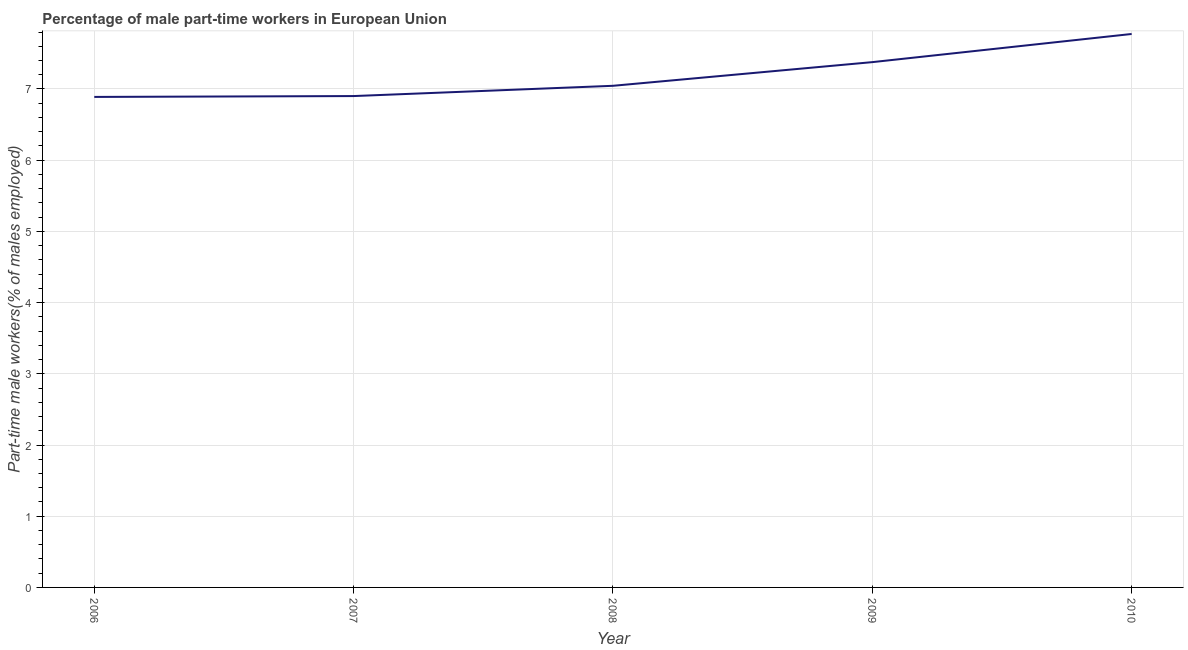What is the percentage of part-time male workers in 2007?
Provide a short and direct response. 6.9. Across all years, what is the maximum percentage of part-time male workers?
Your answer should be compact. 7.77. Across all years, what is the minimum percentage of part-time male workers?
Provide a short and direct response. 6.89. In which year was the percentage of part-time male workers minimum?
Ensure brevity in your answer.  2006. What is the sum of the percentage of part-time male workers?
Offer a very short reply. 35.98. What is the difference between the percentage of part-time male workers in 2008 and 2010?
Make the answer very short. -0.73. What is the average percentage of part-time male workers per year?
Your answer should be compact. 7.2. What is the median percentage of part-time male workers?
Offer a very short reply. 7.04. In how many years, is the percentage of part-time male workers greater than 2.2 %?
Offer a very short reply. 5. Do a majority of the years between 2006 and 2008 (inclusive) have percentage of part-time male workers greater than 5.8 %?
Make the answer very short. Yes. What is the ratio of the percentage of part-time male workers in 2006 to that in 2009?
Give a very brief answer. 0.93. Is the difference between the percentage of part-time male workers in 2006 and 2009 greater than the difference between any two years?
Ensure brevity in your answer.  No. What is the difference between the highest and the second highest percentage of part-time male workers?
Offer a terse response. 0.4. Is the sum of the percentage of part-time male workers in 2006 and 2009 greater than the maximum percentage of part-time male workers across all years?
Provide a short and direct response. Yes. What is the difference between the highest and the lowest percentage of part-time male workers?
Ensure brevity in your answer.  0.88. In how many years, is the percentage of part-time male workers greater than the average percentage of part-time male workers taken over all years?
Make the answer very short. 2. How many lines are there?
Ensure brevity in your answer.  1. How many years are there in the graph?
Offer a terse response. 5. What is the difference between two consecutive major ticks on the Y-axis?
Give a very brief answer. 1. Are the values on the major ticks of Y-axis written in scientific E-notation?
Your answer should be very brief. No. Does the graph contain grids?
Your answer should be compact. Yes. What is the title of the graph?
Provide a short and direct response. Percentage of male part-time workers in European Union. What is the label or title of the Y-axis?
Your answer should be very brief. Part-time male workers(% of males employed). What is the Part-time male workers(% of males employed) in 2006?
Your answer should be very brief. 6.89. What is the Part-time male workers(% of males employed) in 2007?
Provide a succinct answer. 6.9. What is the Part-time male workers(% of males employed) in 2008?
Ensure brevity in your answer.  7.04. What is the Part-time male workers(% of males employed) of 2009?
Provide a succinct answer. 7.38. What is the Part-time male workers(% of males employed) of 2010?
Offer a very short reply. 7.77. What is the difference between the Part-time male workers(% of males employed) in 2006 and 2007?
Your answer should be very brief. -0.01. What is the difference between the Part-time male workers(% of males employed) in 2006 and 2008?
Give a very brief answer. -0.16. What is the difference between the Part-time male workers(% of males employed) in 2006 and 2009?
Your answer should be compact. -0.49. What is the difference between the Part-time male workers(% of males employed) in 2006 and 2010?
Your answer should be very brief. -0.88. What is the difference between the Part-time male workers(% of males employed) in 2007 and 2008?
Offer a very short reply. -0.14. What is the difference between the Part-time male workers(% of males employed) in 2007 and 2009?
Provide a succinct answer. -0.48. What is the difference between the Part-time male workers(% of males employed) in 2007 and 2010?
Your answer should be very brief. -0.87. What is the difference between the Part-time male workers(% of males employed) in 2008 and 2009?
Give a very brief answer. -0.33. What is the difference between the Part-time male workers(% of males employed) in 2008 and 2010?
Give a very brief answer. -0.73. What is the difference between the Part-time male workers(% of males employed) in 2009 and 2010?
Make the answer very short. -0.4. What is the ratio of the Part-time male workers(% of males employed) in 2006 to that in 2007?
Offer a very short reply. 1. What is the ratio of the Part-time male workers(% of males employed) in 2006 to that in 2008?
Your response must be concise. 0.98. What is the ratio of the Part-time male workers(% of males employed) in 2006 to that in 2009?
Offer a very short reply. 0.93. What is the ratio of the Part-time male workers(% of males employed) in 2006 to that in 2010?
Your answer should be very brief. 0.89. What is the ratio of the Part-time male workers(% of males employed) in 2007 to that in 2008?
Ensure brevity in your answer.  0.98. What is the ratio of the Part-time male workers(% of males employed) in 2007 to that in 2009?
Give a very brief answer. 0.94. What is the ratio of the Part-time male workers(% of males employed) in 2007 to that in 2010?
Keep it short and to the point. 0.89. What is the ratio of the Part-time male workers(% of males employed) in 2008 to that in 2009?
Give a very brief answer. 0.95. What is the ratio of the Part-time male workers(% of males employed) in 2008 to that in 2010?
Offer a terse response. 0.91. What is the ratio of the Part-time male workers(% of males employed) in 2009 to that in 2010?
Keep it short and to the point. 0.95. 